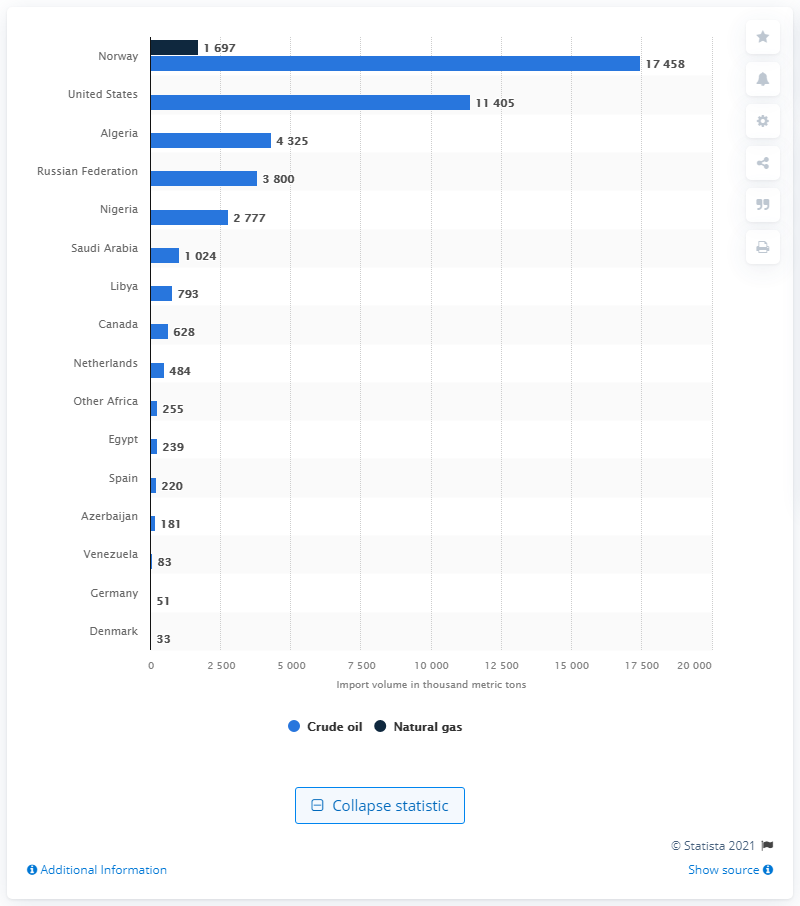Draw attention to some important aspects in this diagram. The main supplier of both crude oil and natural gas for the UK is Norway. Norway was the second largest importer of crude oil and natural gas from the United States. 